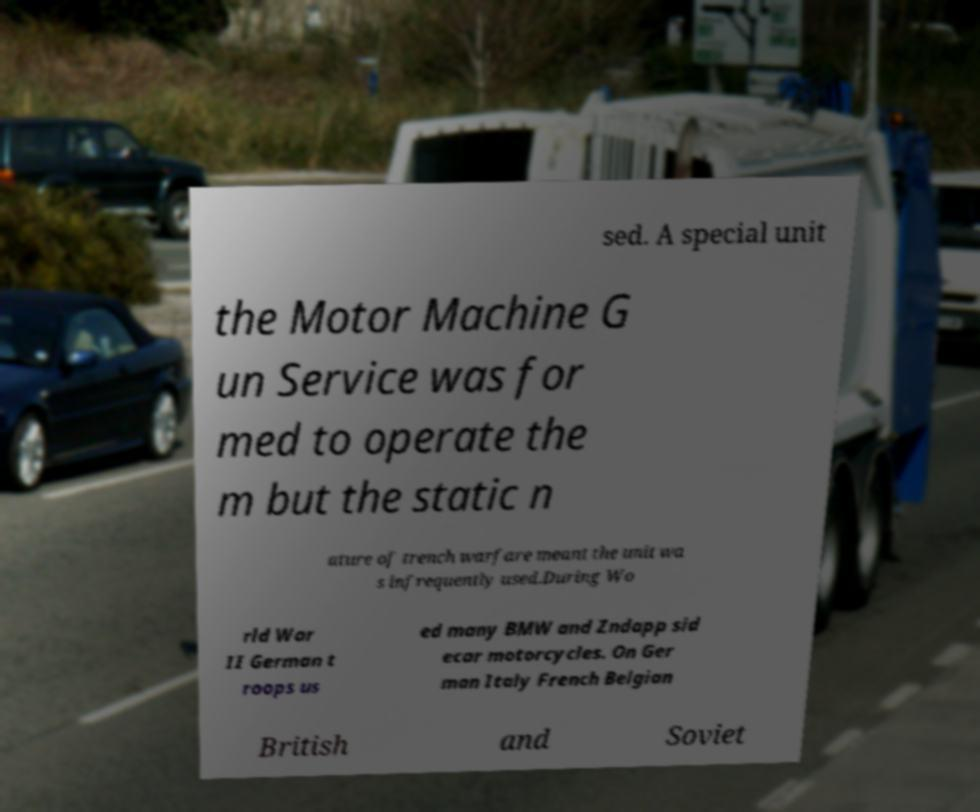Can you accurately transcribe the text from the provided image for me? sed. A special unit the Motor Machine G un Service was for med to operate the m but the static n ature of trench warfare meant the unit wa s infrequently used.During Wo rld War II German t roops us ed many BMW and Zndapp sid ecar motorcycles. On Ger man Italy French Belgian British and Soviet 